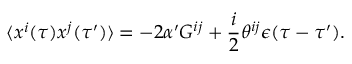Convert formula to latex. <formula><loc_0><loc_0><loc_500><loc_500>\langle x ^ { i } ( \tau ) x ^ { j } ( \tau ^ { \prime } ) \rangle = - 2 \alpha ^ { \prime } G ^ { i j } + \frac { i } { 2 } \theta ^ { i j } \epsilon ( \tau - \tau ^ { \prime } ) .</formula> 